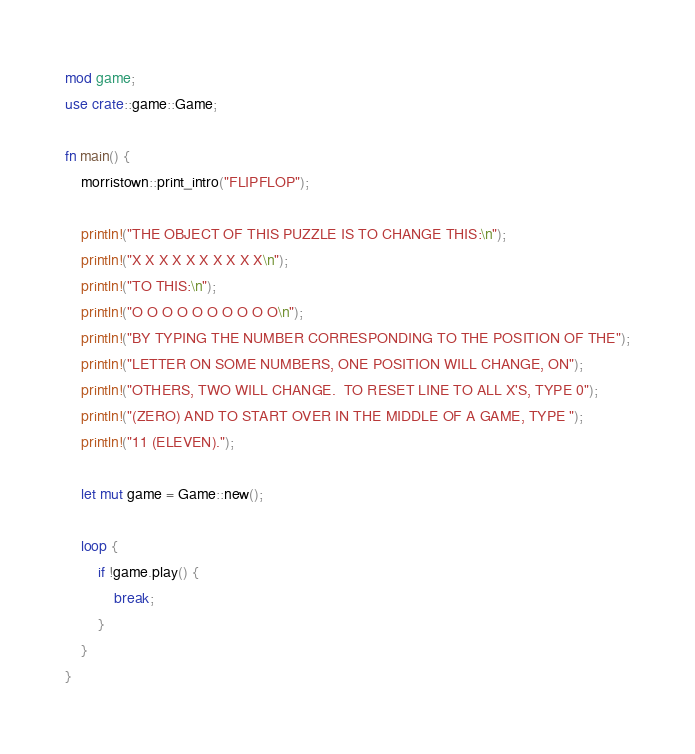<code> <loc_0><loc_0><loc_500><loc_500><_Rust_>mod game;
use crate::game::Game;

fn main() {
    morristown::print_intro("FLIPFLOP");

    println!("THE OBJECT OF THIS PUZZLE IS TO CHANGE THIS:\n");
    println!("X X X X X X X X X X\n");
    println!("TO THIS:\n");
    println!("O O O O O O O O O O\n");
    println!("BY TYPING THE NUMBER CORRESPONDING TO THE POSITION OF THE");
    println!("LETTER ON SOME NUMBERS, ONE POSITION WILL CHANGE, ON");
    println!("OTHERS, TWO WILL CHANGE.  TO RESET LINE TO ALL X'S, TYPE 0");
    println!("(ZERO) AND TO START OVER IN THE MIDDLE OF A GAME, TYPE ");
    println!("11 (ELEVEN).");

    let mut game = Game::new();

    loop {
        if !game.play() {
            break;
        }
    }
}
</code> 